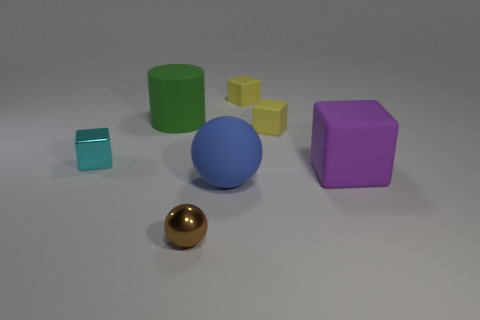What material do you think the objects are made of? The objects appear to be made of different materials. The shiny gold ball suggests a polished metal, perhaps brass or gold in color. The matte ball has the appearance of rubber due to its dull finish. The purple object seems like it could be plastic, and the cylinder and cube also have a plastic-like texture. The small translucent cube looks like glass or translucent plastic. 